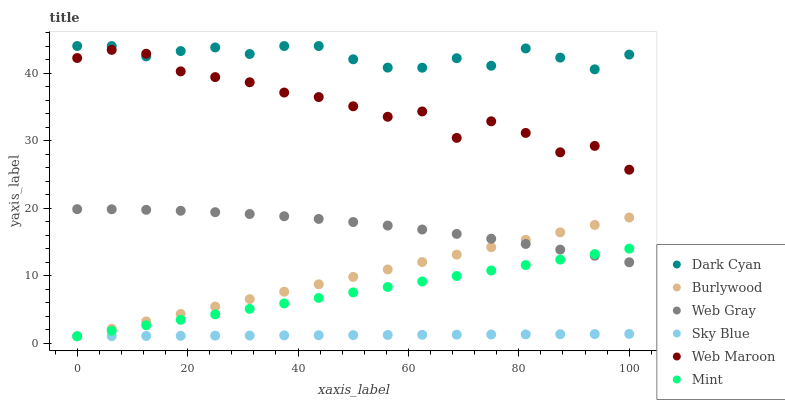Does Sky Blue have the minimum area under the curve?
Answer yes or no. Yes. Does Dark Cyan have the maximum area under the curve?
Answer yes or no. Yes. Does Burlywood have the minimum area under the curve?
Answer yes or no. No. Does Burlywood have the maximum area under the curve?
Answer yes or no. No. Is Sky Blue the smoothest?
Answer yes or no. Yes. Is Web Maroon the roughest?
Answer yes or no. Yes. Is Burlywood the smoothest?
Answer yes or no. No. Is Burlywood the roughest?
Answer yes or no. No. Does Burlywood have the lowest value?
Answer yes or no. Yes. Does Web Maroon have the lowest value?
Answer yes or no. No. Does Dark Cyan have the highest value?
Answer yes or no. Yes. Does Burlywood have the highest value?
Answer yes or no. No. Is Burlywood less than Web Maroon?
Answer yes or no. Yes. Is Web Gray greater than Sky Blue?
Answer yes or no. Yes. Does Web Gray intersect Burlywood?
Answer yes or no. Yes. Is Web Gray less than Burlywood?
Answer yes or no. No. Is Web Gray greater than Burlywood?
Answer yes or no. No. Does Burlywood intersect Web Maroon?
Answer yes or no. No. 